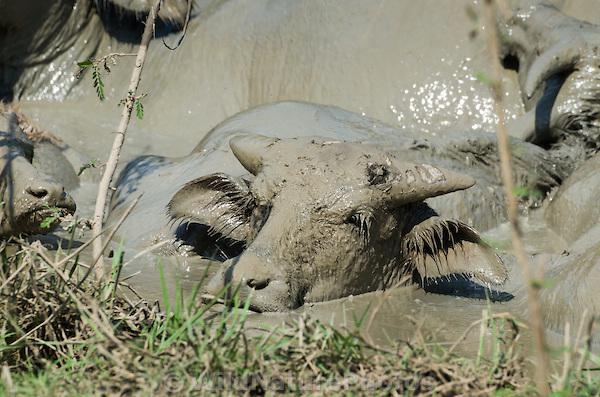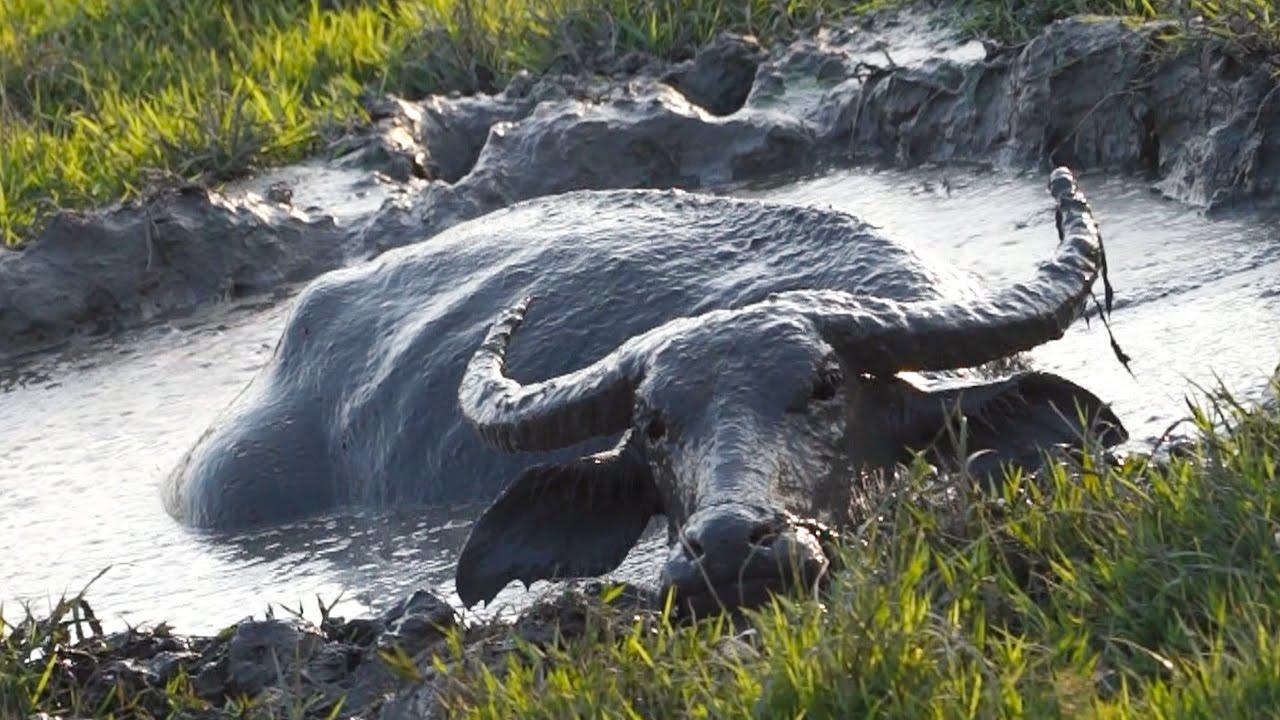The first image is the image on the left, the second image is the image on the right. For the images shown, is this caption "All water buffalo are in mud that reaches at least to their chest, and no image contains more than three water buffalo." true? Answer yes or no. Yes. The first image is the image on the left, the second image is the image on the right. For the images shown, is this caption "The cow in each image is standing past their legs in the mud." true? Answer yes or no. Yes. 